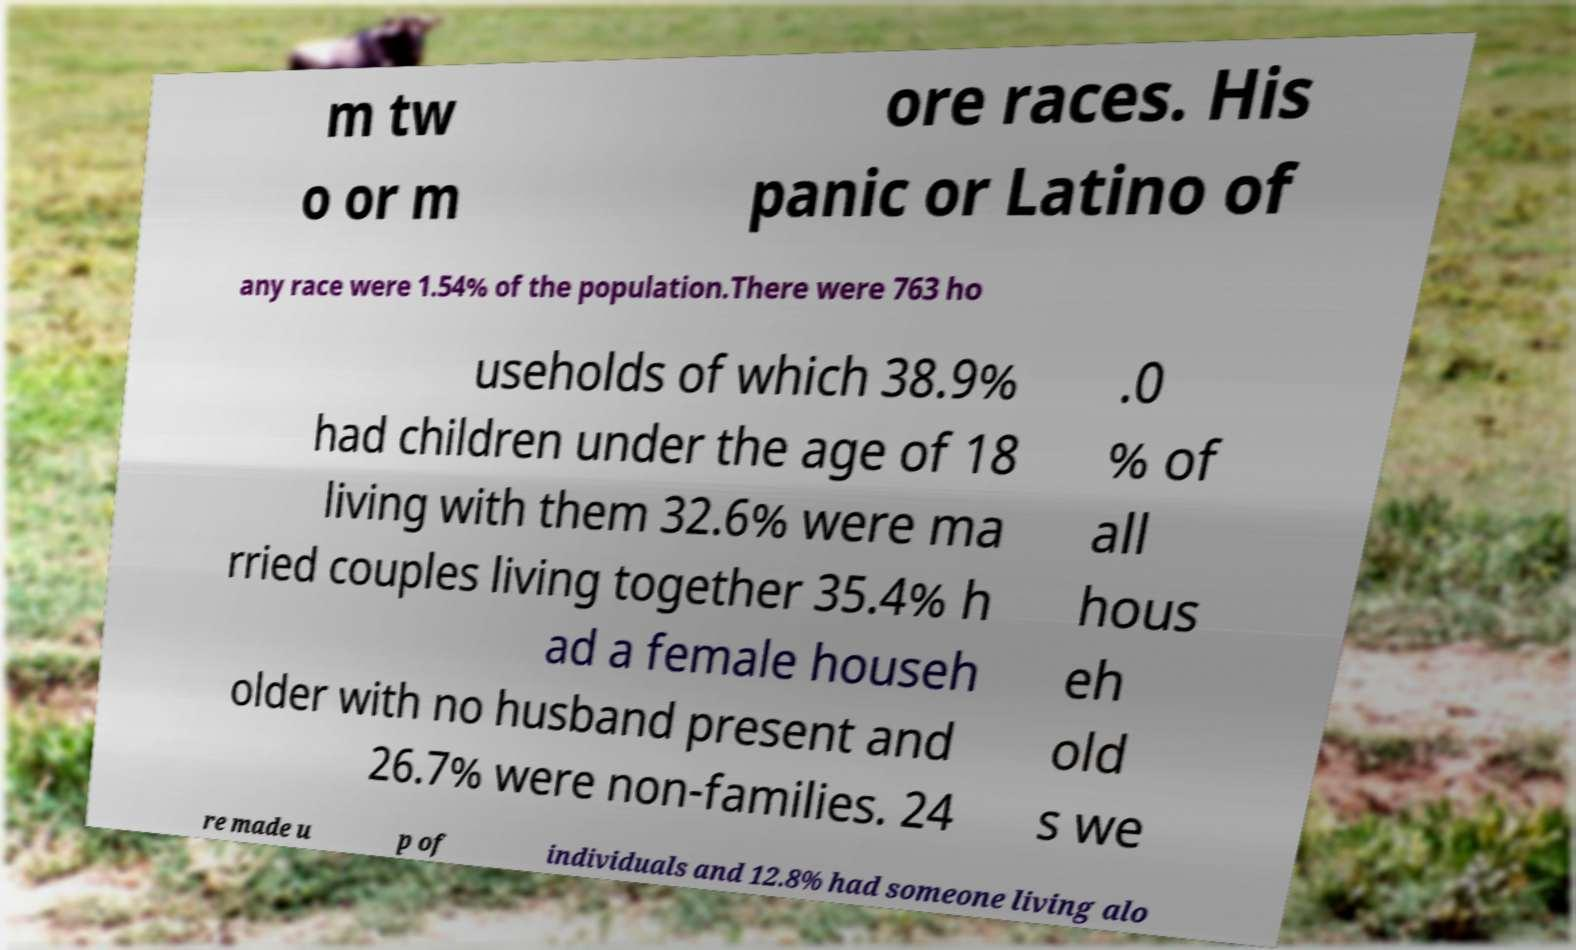There's text embedded in this image that I need extracted. Can you transcribe it verbatim? m tw o or m ore races. His panic or Latino of any race were 1.54% of the population.There were 763 ho useholds of which 38.9% had children under the age of 18 living with them 32.6% were ma rried couples living together 35.4% h ad a female househ older with no husband present and 26.7% were non-families. 24 .0 % of all hous eh old s we re made u p of individuals and 12.8% had someone living alo 